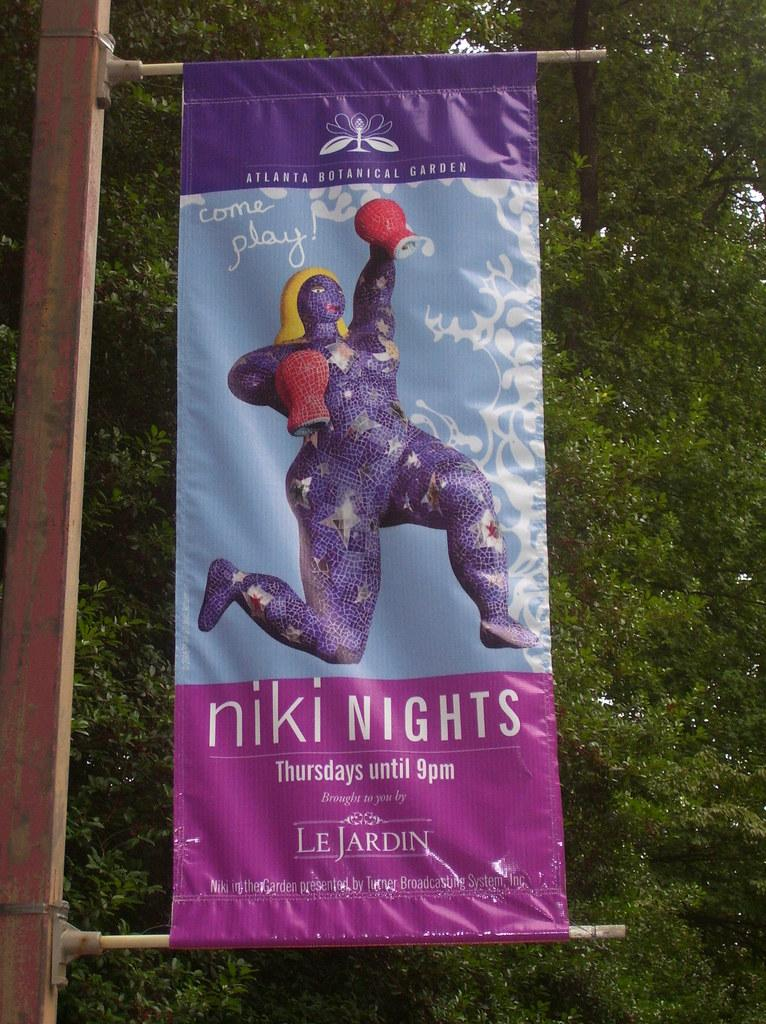<image>
Relay a brief, clear account of the picture shown. A banner for niki nights on a public pole. 